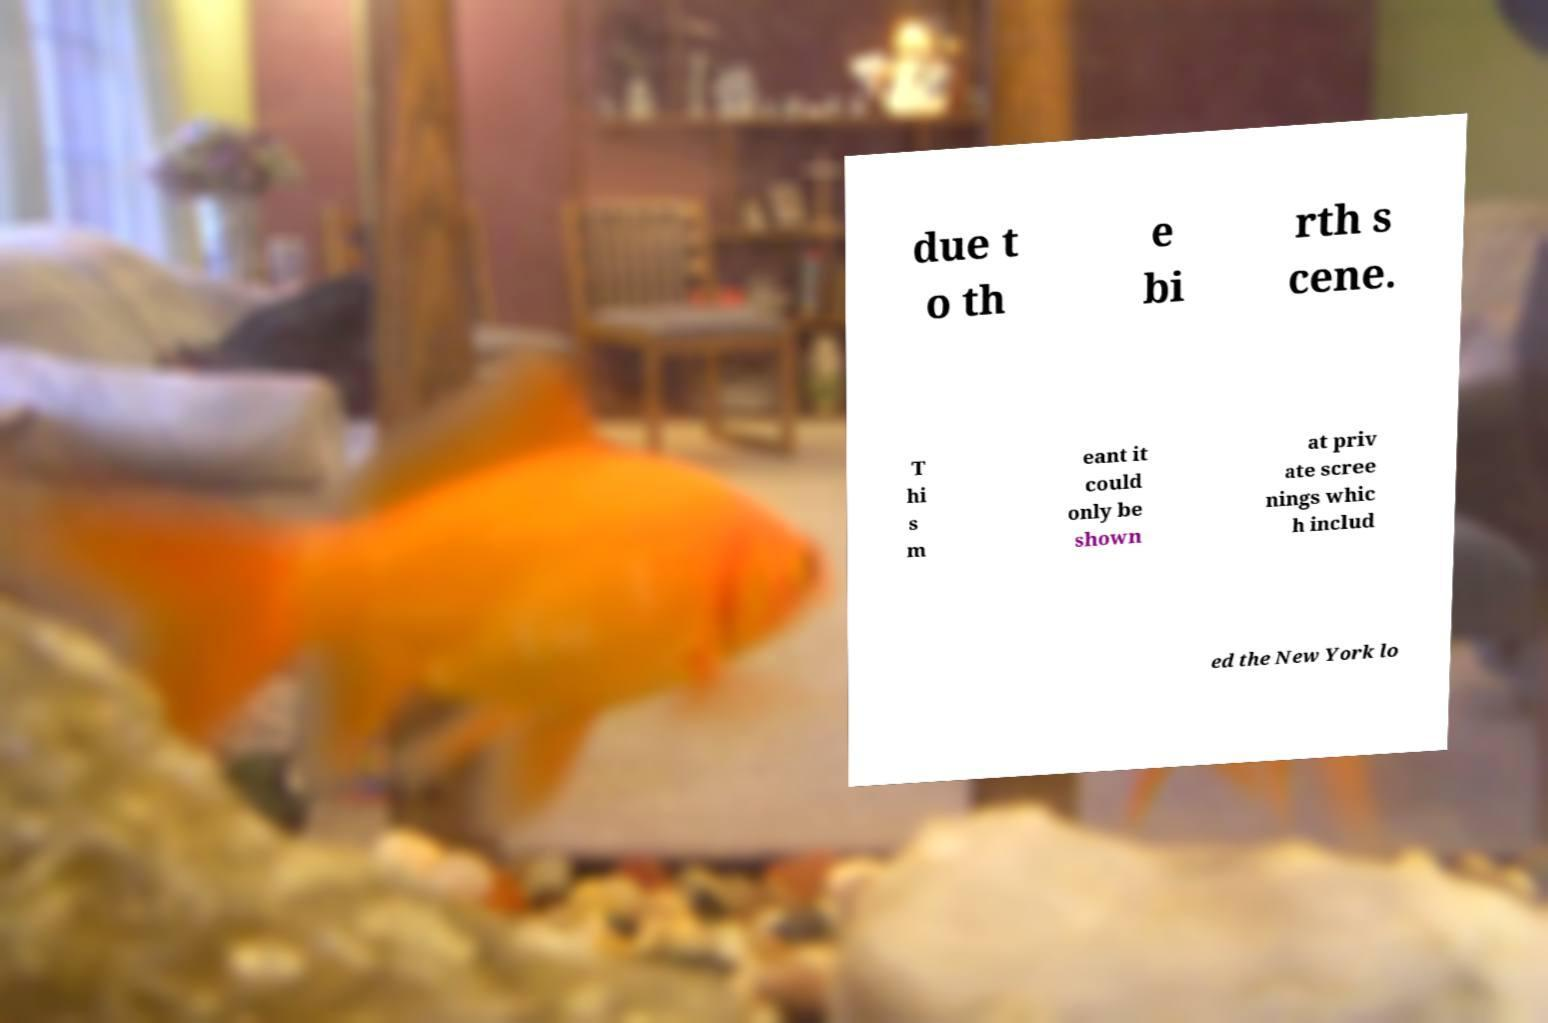Could you extract and type out the text from this image? due t o th e bi rth s cene. T hi s m eant it could only be shown at priv ate scree nings whic h includ ed the New York lo 